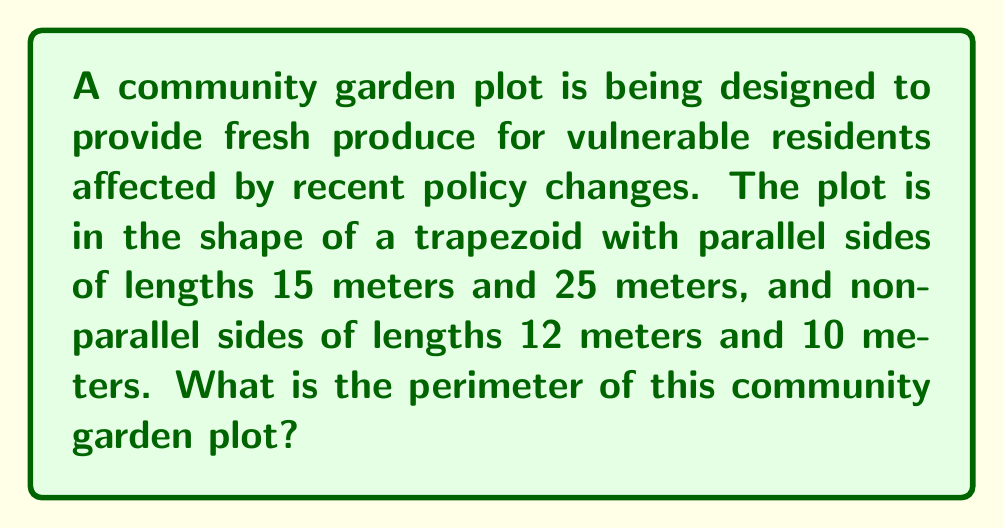Give your solution to this math problem. To find the perimeter of the trapezoid-shaped community garden plot, we need to add up the lengths of all four sides:

1. Given:
   - Parallel side 1: $a = 15$ meters
   - Parallel side 2: $b = 25$ meters
   - Non-parallel side 1: $c = 12$ meters
   - Non-parallel side 2: $d = 10$ meters

2. The perimeter formula for a trapezoid is:
   $$ P = a + b + c + d $$

3. Substituting the given values:
   $$ P = 15 + 25 + 12 + 10 $$

4. Calculating the sum:
   $$ P = 62 $$

Therefore, the perimeter of the community garden plot is 62 meters.
Answer: 62 meters 